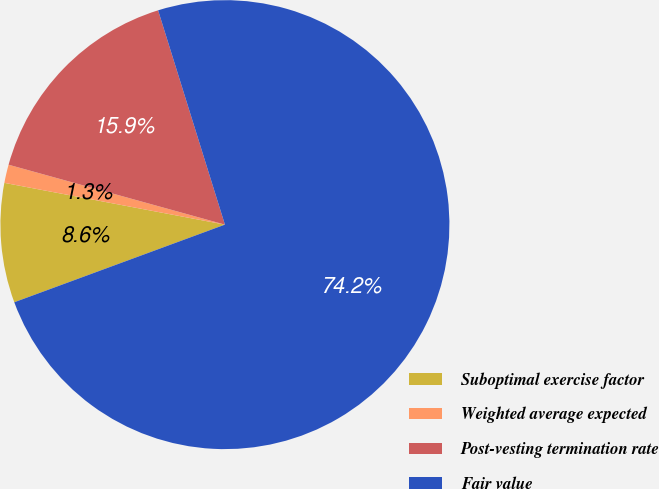<chart> <loc_0><loc_0><loc_500><loc_500><pie_chart><fcel>Suboptimal exercise factor<fcel>Weighted average expected<fcel>Post-vesting termination rate<fcel>Fair value<nl><fcel>8.6%<fcel>1.32%<fcel>15.89%<fcel>74.19%<nl></chart> 